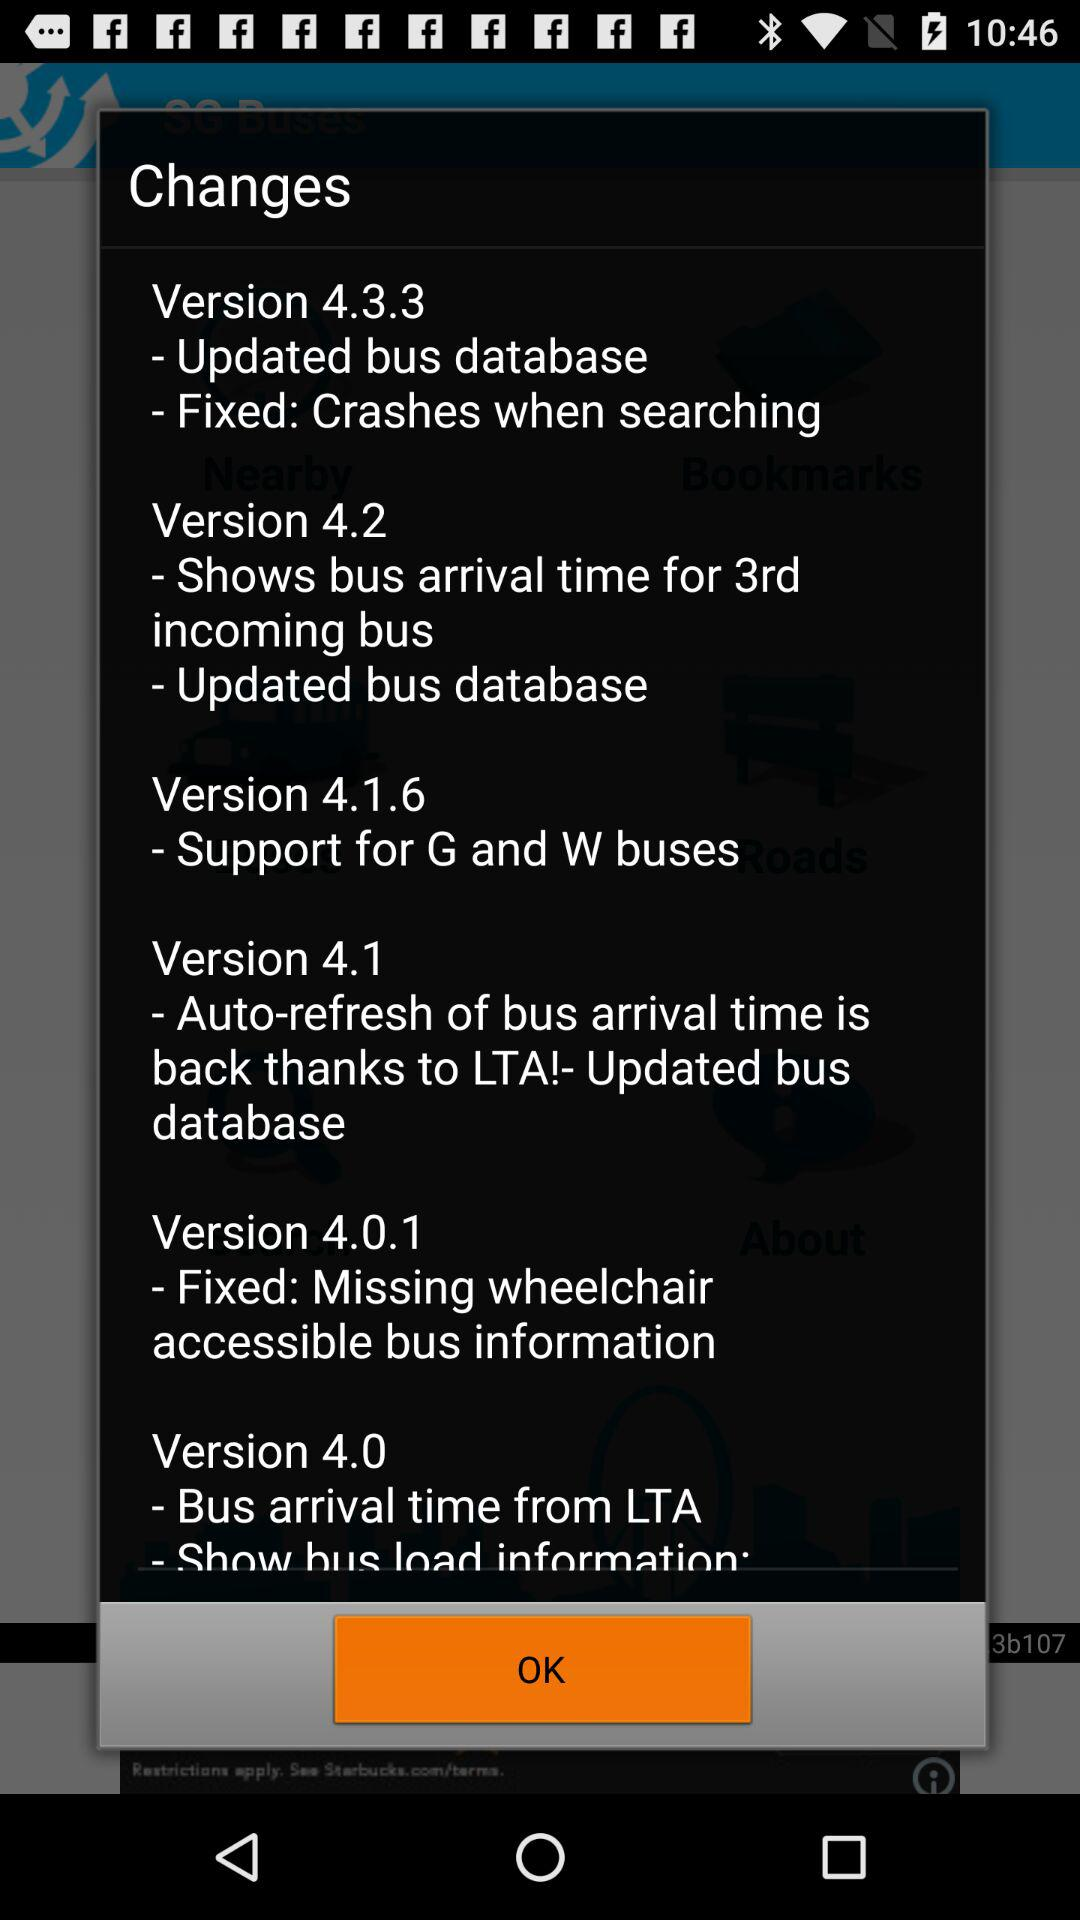How many versions are there?
When the provided information is insufficient, respond with <no answer>. <no answer> 